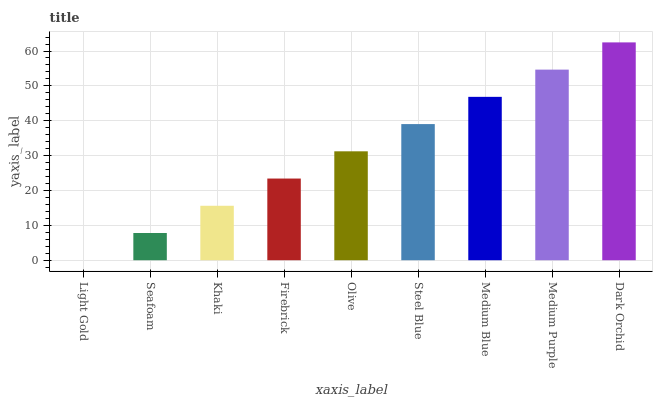Is Seafoam the minimum?
Answer yes or no. No. Is Seafoam the maximum?
Answer yes or no. No. Is Seafoam greater than Light Gold?
Answer yes or no. Yes. Is Light Gold less than Seafoam?
Answer yes or no. Yes. Is Light Gold greater than Seafoam?
Answer yes or no. No. Is Seafoam less than Light Gold?
Answer yes or no. No. Is Olive the high median?
Answer yes or no. Yes. Is Olive the low median?
Answer yes or no. Yes. Is Medium Purple the high median?
Answer yes or no. No. Is Seafoam the low median?
Answer yes or no. No. 